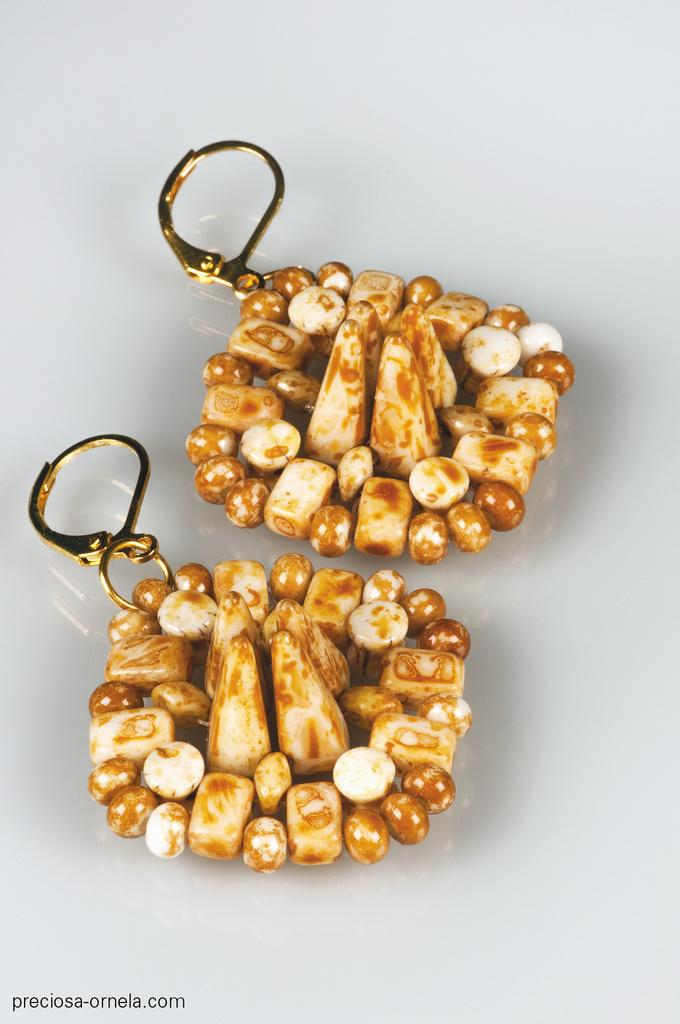What type of jewelry is visible on the surface in the image? There are earrings on a surface in the image. What color is the surface where the earrings are placed? The surface is white in color. Is there any text visible in the image? Yes, there is some text in the left bottom of the image. How does the wind affect the thrill of the woman in the image? There is no wind, thrill, or woman present in the image; it only features earrings on a white surface with some text. 